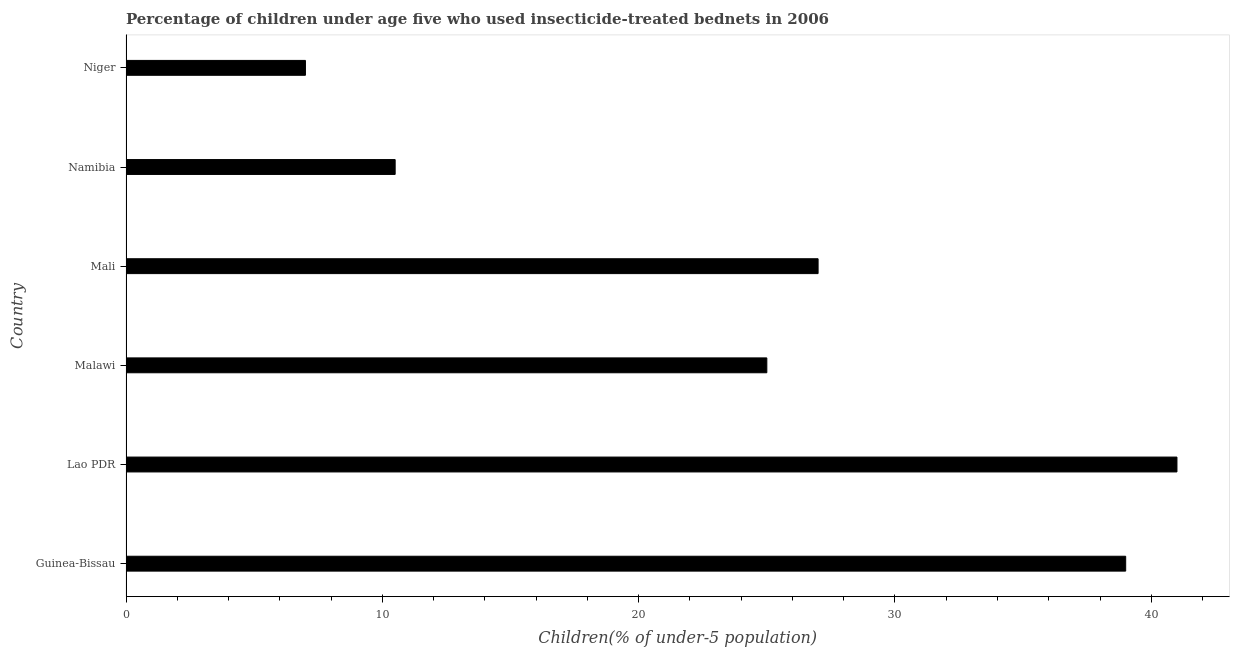Does the graph contain any zero values?
Your answer should be compact. No. Does the graph contain grids?
Your answer should be very brief. No. What is the title of the graph?
Keep it short and to the point. Percentage of children under age five who used insecticide-treated bednets in 2006. What is the label or title of the X-axis?
Your answer should be compact. Children(% of under-5 population). What is the label or title of the Y-axis?
Offer a very short reply. Country. Across all countries, what is the maximum percentage of children who use of insecticide-treated bed nets?
Your response must be concise. 41. In which country was the percentage of children who use of insecticide-treated bed nets maximum?
Offer a terse response. Lao PDR. In which country was the percentage of children who use of insecticide-treated bed nets minimum?
Provide a short and direct response. Niger. What is the sum of the percentage of children who use of insecticide-treated bed nets?
Provide a succinct answer. 149.5. What is the difference between the percentage of children who use of insecticide-treated bed nets in Guinea-Bissau and Malawi?
Ensure brevity in your answer.  14. What is the average percentage of children who use of insecticide-treated bed nets per country?
Provide a short and direct response. 24.92. In how many countries, is the percentage of children who use of insecticide-treated bed nets greater than 36 %?
Your answer should be compact. 2. What is the ratio of the percentage of children who use of insecticide-treated bed nets in Guinea-Bissau to that in Namibia?
Offer a very short reply. 3.71. Is the percentage of children who use of insecticide-treated bed nets in Lao PDR less than that in Namibia?
Provide a short and direct response. No. What is the difference between the highest and the lowest percentage of children who use of insecticide-treated bed nets?
Offer a very short reply. 34. In how many countries, is the percentage of children who use of insecticide-treated bed nets greater than the average percentage of children who use of insecticide-treated bed nets taken over all countries?
Offer a very short reply. 4. Are all the bars in the graph horizontal?
Offer a very short reply. Yes. How many countries are there in the graph?
Offer a very short reply. 6. What is the Children(% of under-5 population) of Lao PDR?
Your answer should be compact. 41. What is the Children(% of under-5 population) of Malawi?
Provide a succinct answer. 25. What is the Children(% of under-5 population) in Mali?
Make the answer very short. 27. What is the difference between the Children(% of under-5 population) in Guinea-Bissau and Lao PDR?
Your answer should be compact. -2. What is the difference between the Children(% of under-5 population) in Guinea-Bissau and Namibia?
Keep it short and to the point. 28.5. What is the difference between the Children(% of under-5 population) in Guinea-Bissau and Niger?
Provide a short and direct response. 32. What is the difference between the Children(% of under-5 population) in Lao PDR and Malawi?
Your answer should be very brief. 16. What is the difference between the Children(% of under-5 population) in Lao PDR and Mali?
Give a very brief answer. 14. What is the difference between the Children(% of under-5 population) in Lao PDR and Namibia?
Keep it short and to the point. 30.5. What is the difference between the Children(% of under-5 population) in Malawi and Mali?
Make the answer very short. -2. What is the difference between the Children(% of under-5 population) in Malawi and Namibia?
Your answer should be very brief. 14.5. What is the difference between the Children(% of under-5 population) in Mali and Niger?
Your answer should be compact. 20. What is the difference between the Children(% of under-5 population) in Namibia and Niger?
Offer a terse response. 3.5. What is the ratio of the Children(% of under-5 population) in Guinea-Bissau to that in Lao PDR?
Provide a succinct answer. 0.95. What is the ratio of the Children(% of under-5 population) in Guinea-Bissau to that in Malawi?
Your answer should be very brief. 1.56. What is the ratio of the Children(% of under-5 population) in Guinea-Bissau to that in Mali?
Give a very brief answer. 1.44. What is the ratio of the Children(% of under-5 population) in Guinea-Bissau to that in Namibia?
Offer a very short reply. 3.71. What is the ratio of the Children(% of under-5 population) in Guinea-Bissau to that in Niger?
Keep it short and to the point. 5.57. What is the ratio of the Children(% of under-5 population) in Lao PDR to that in Malawi?
Your answer should be compact. 1.64. What is the ratio of the Children(% of under-5 population) in Lao PDR to that in Mali?
Provide a short and direct response. 1.52. What is the ratio of the Children(% of under-5 population) in Lao PDR to that in Namibia?
Your answer should be compact. 3.9. What is the ratio of the Children(% of under-5 population) in Lao PDR to that in Niger?
Provide a short and direct response. 5.86. What is the ratio of the Children(% of under-5 population) in Malawi to that in Mali?
Offer a terse response. 0.93. What is the ratio of the Children(% of under-5 population) in Malawi to that in Namibia?
Offer a terse response. 2.38. What is the ratio of the Children(% of under-5 population) in Malawi to that in Niger?
Your answer should be compact. 3.57. What is the ratio of the Children(% of under-5 population) in Mali to that in Namibia?
Offer a terse response. 2.57. What is the ratio of the Children(% of under-5 population) in Mali to that in Niger?
Your answer should be compact. 3.86. 